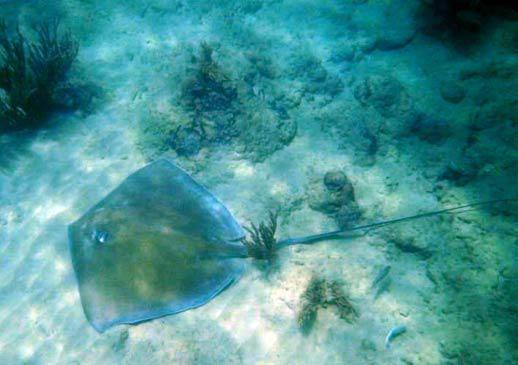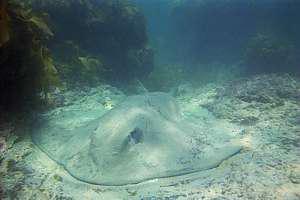The first image is the image on the left, the second image is the image on the right. Analyze the images presented: Is the assertion "there are two stingrays per image pair" valid? Answer yes or no. Yes. 